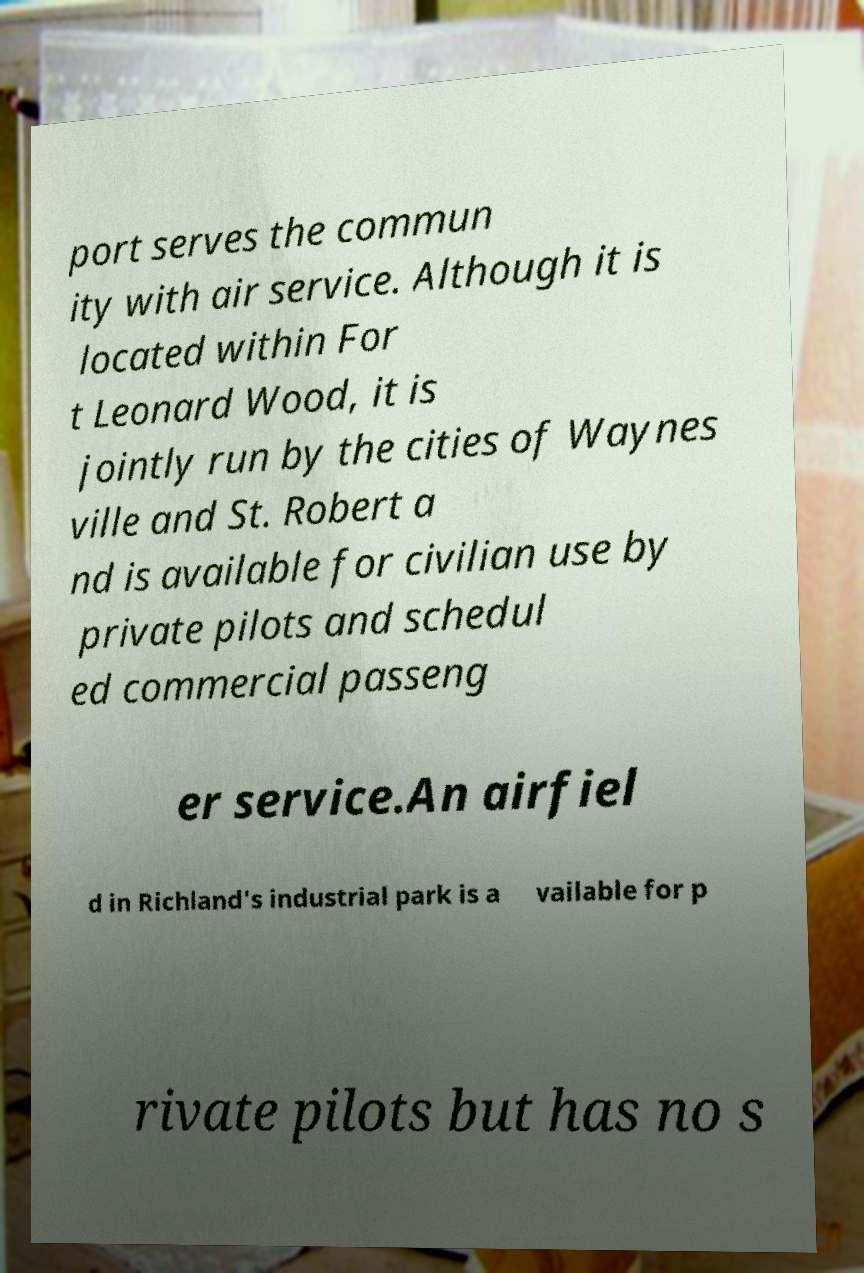I need the written content from this picture converted into text. Can you do that? port serves the commun ity with air service. Although it is located within For t Leonard Wood, it is jointly run by the cities of Waynes ville and St. Robert a nd is available for civilian use by private pilots and schedul ed commercial passeng er service.An airfiel d in Richland's industrial park is a vailable for p rivate pilots but has no s 